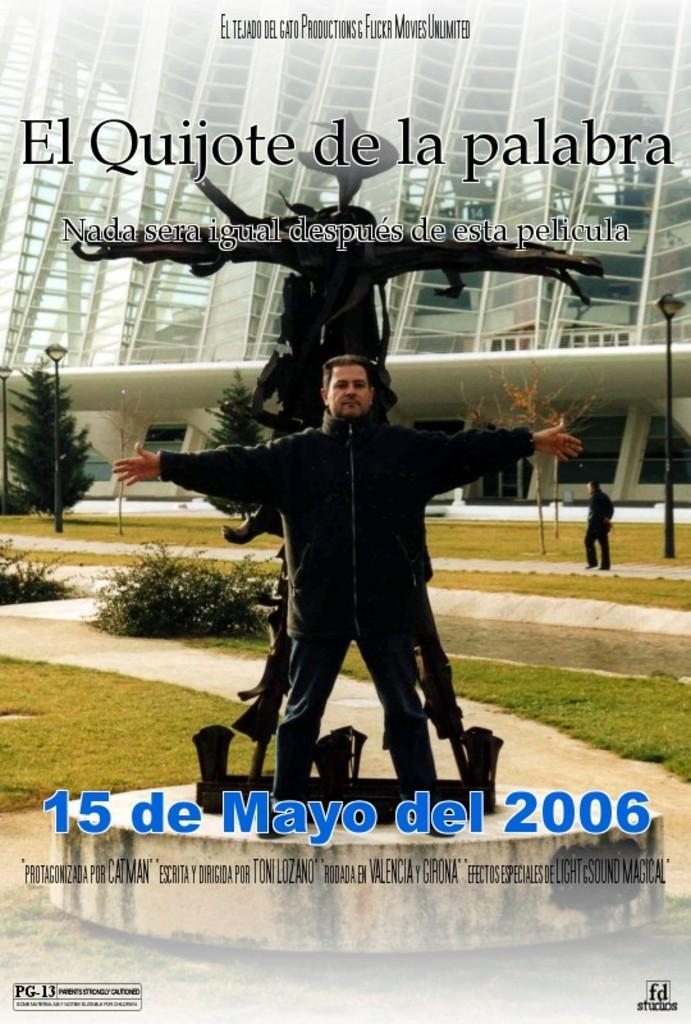<image>
Summarize the visual content of the image. A poster advertising a Spanish language performance on May 15, 2006. 